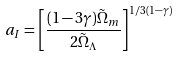<formula> <loc_0><loc_0><loc_500><loc_500>a _ { I } = \left [ \frac { ( 1 - 3 \gamma ) \tilde { \Omega } _ { m } } { 2 \tilde { \Omega } _ { \Lambda } } \right ] ^ { 1 / 3 ( 1 - \gamma ) } \,</formula> 